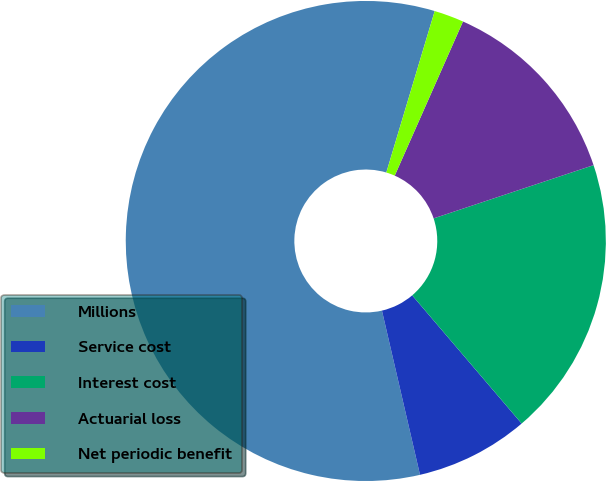Convert chart. <chart><loc_0><loc_0><loc_500><loc_500><pie_chart><fcel>Millions<fcel>Service cost<fcel>Interest cost<fcel>Actuarial loss<fcel>Net periodic benefit<nl><fcel>58.26%<fcel>7.62%<fcel>18.87%<fcel>13.25%<fcel>2.0%<nl></chart> 